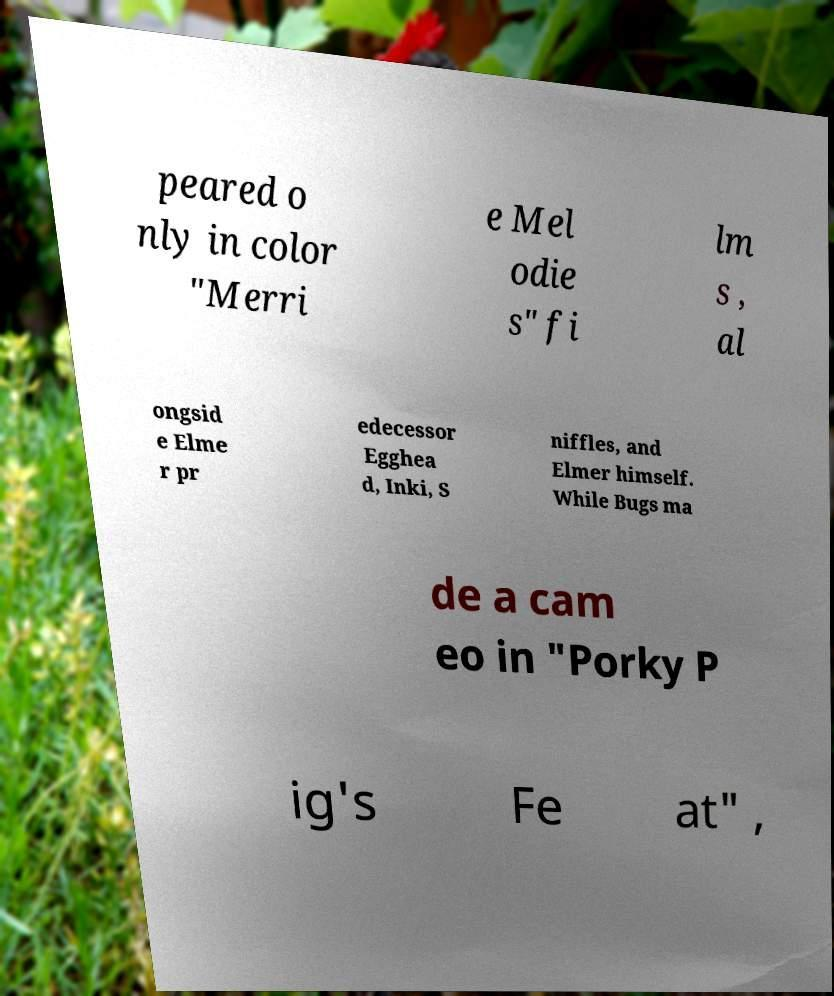Can you read and provide the text displayed in the image?This photo seems to have some interesting text. Can you extract and type it out for me? peared o nly in color "Merri e Mel odie s" fi lm s , al ongsid e Elme r pr edecessor Egghea d, Inki, S niffles, and Elmer himself. While Bugs ma de a cam eo in "Porky P ig's Fe at" , 